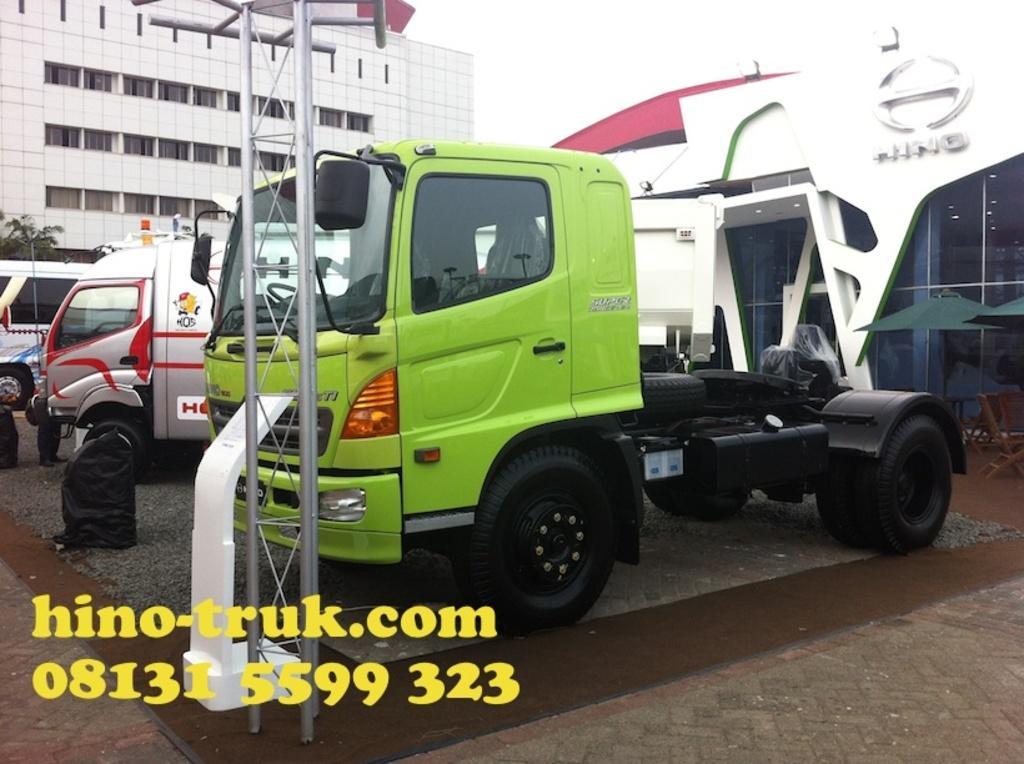Can you describe this image briefly? In the center of the image there is a truck. In the background there is a building, trucks, chairs and sky. 